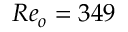Convert formula to latex. <formula><loc_0><loc_0><loc_500><loc_500>R e _ { o } = 3 4 9</formula> 